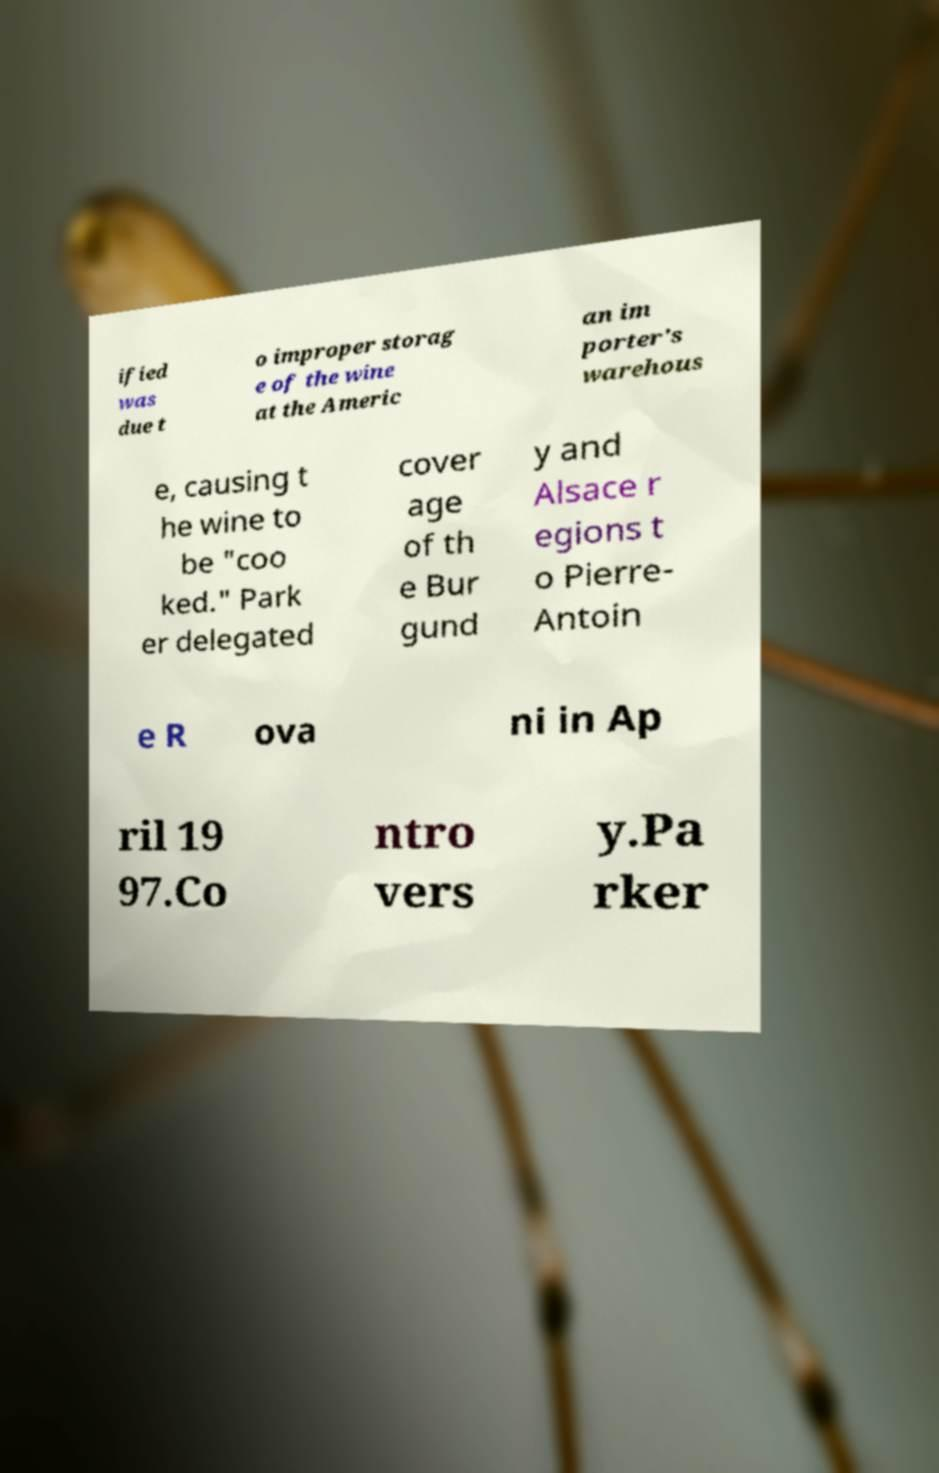Can you read and provide the text displayed in the image?This photo seems to have some interesting text. Can you extract and type it out for me? ified was due t o improper storag e of the wine at the Americ an im porter's warehous e, causing t he wine to be "coo ked." Park er delegated cover age of th e Bur gund y and Alsace r egions t o Pierre- Antoin e R ova ni in Ap ril 19 97.Co ntro vers y.Pa rker 